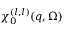Convert formula to latex. <formula><loc_0><loc_0><loc_500><loc_500>\chi _ { 0 } ^ { ( l , l ) } ( q , \Omega )</formula> 